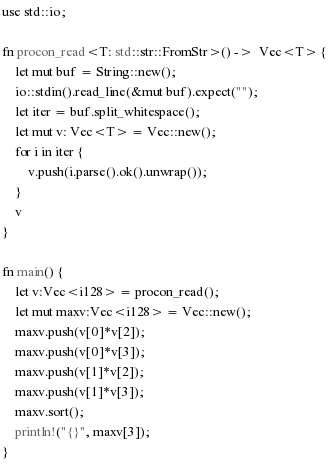Convert code to text. <code><loc_0><loc_0><loc_500><loc_500><_Rust_>use std::io;

fn procon_read<T: std::str::FromStr>() ->  Vec<T> {
    let mut buf = String::new();
    io::stdin().read_line(&mut buf).expect("");
    let iter = buf.split_whitespace();
    let mut v: Vec<T> = Vec::new();
    for i in iter {
        v.push(i.parse().ok().unwrap());
    }
    v
}

fn main() {
    let v:Vec<i128> = procon_read();
    let mut maxv:Vec<i128> = Vec::new();
    maxv.push(v[0]*v[2]);
    maxv.push(v[0]*v[3]);
    maxv.push(v[1]*v[2]);
    maxv.push(v[1]*v[3]);
    maxv.sort();
    println!("{}", maxv[3]);
}</code> 